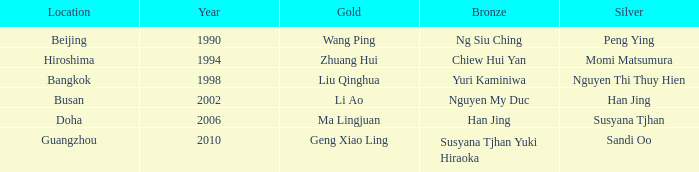What Silver has the Location of Guangzhou? Sandi Oo. 